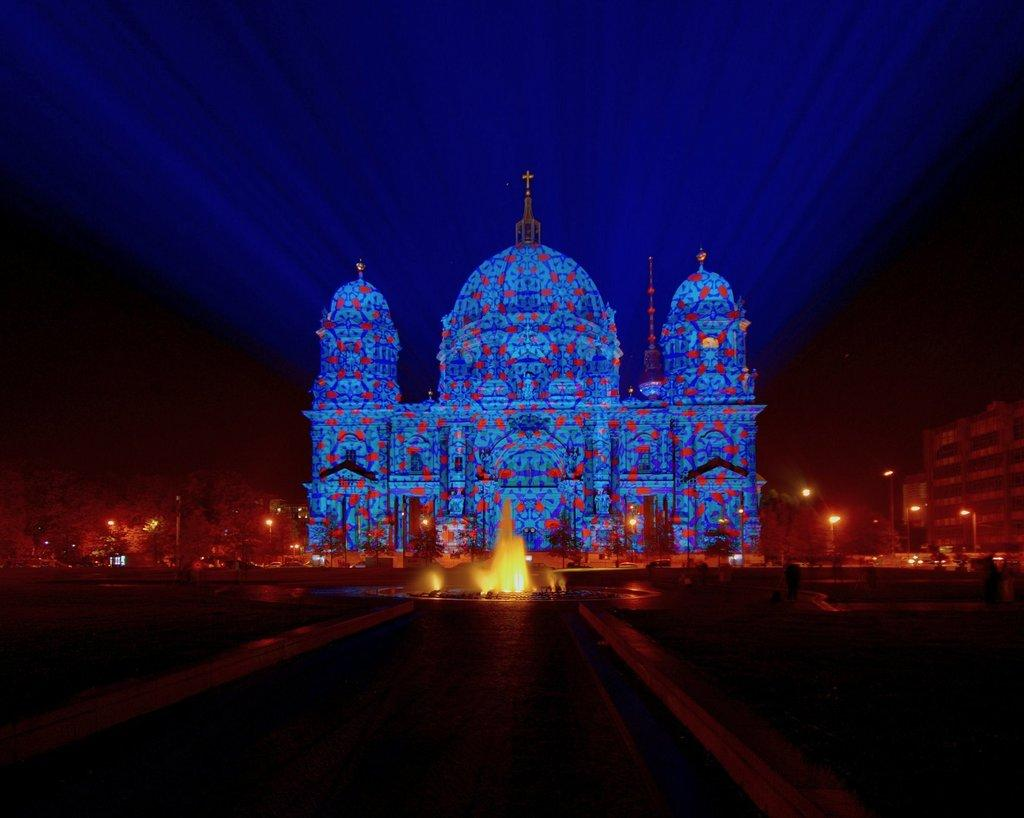What is the general lighting condition in the image? The image is taken in a dark environment. What is the main architectural feature in the image? There is a castle construction with lighting in the image. What type of structure is present near the castle? There is a fountain in the image. What type of artificial lighting is present in the image? Light poles are visible in the image. What type of natural elements are present in the image? There are trees in the image. What type of man-made structures are present in the image? There are buildings in the image. What is the color of the sky in the background of the image? The sky in the background is dark. What type of pen is being used to write on the castle wall in the image? There is no pen or writing on the castle wall in the image. What type of cork is being used to stop the fountain in the image? There is no cork or indication of a need to stop the fountain in the image. 